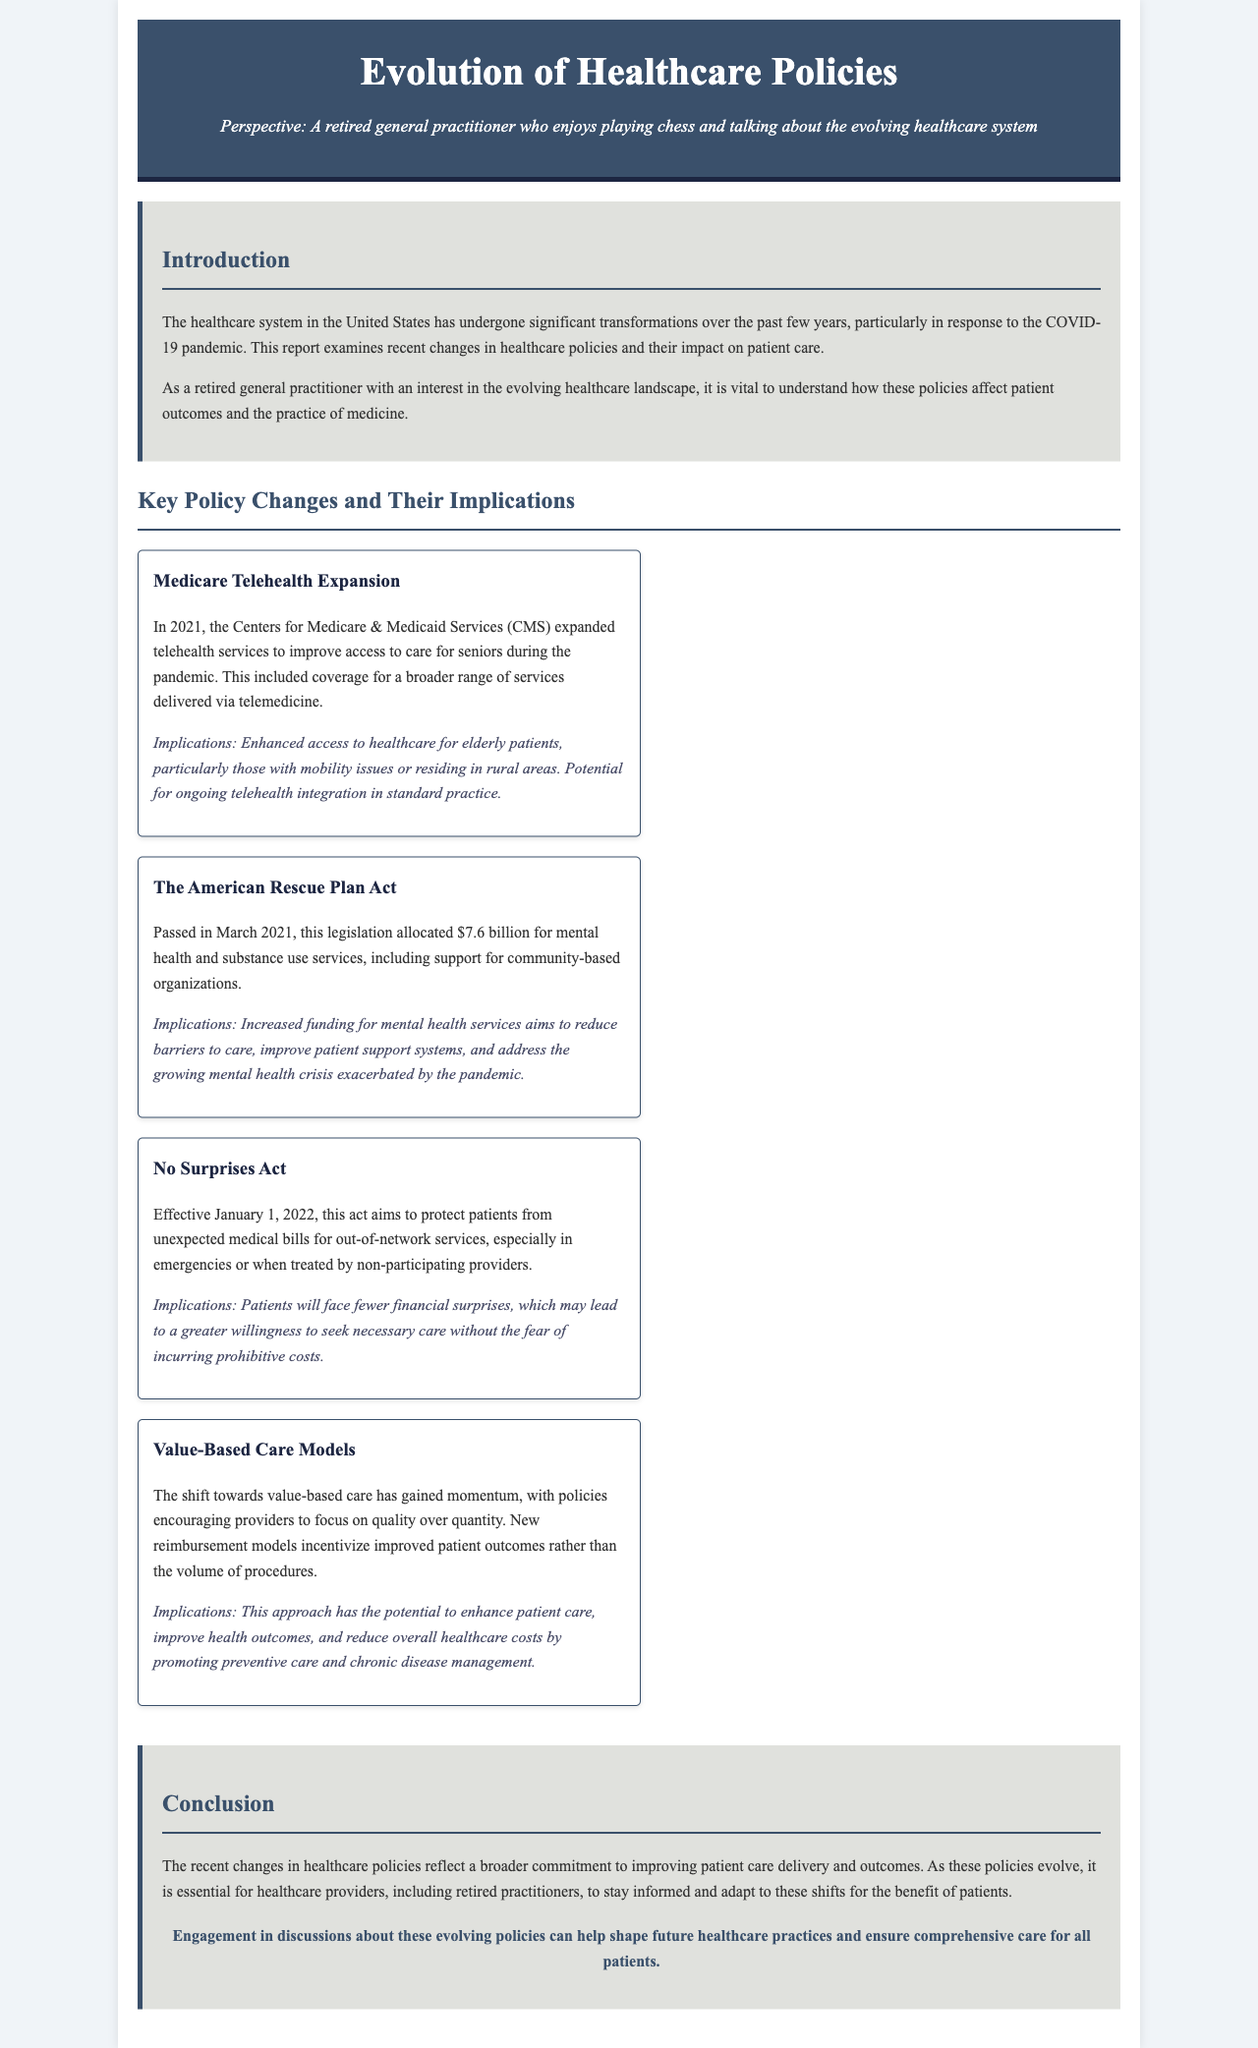What is the title of the report? The title of the report is specified in the heading of the document.
Answer: Evolution of Healthcare Policies Who expanded telehealth services in 2021? The entity responsible for the telehealth expansion is mentioned in the document.
Answer: Centers for Medicare & Medicaid Services What amount was allocated for mental health services under The American Rescue Plan Act? The document states the specific amount allocated for mental health services.
Answer: $7.6 billion When did the No Surprises Act take effect? The effective date of the No Surprises Act is highlighted in the report.
Answer: January 1, 2022 What is the main focus of value-based care models? The document discusses the emphasis of value-based care models.
Answer: Quality over quantity What is one implication of the Medicare Telehealth Expansion? An implication of the telehealth expansion is detailed in the report.
Answer: Enhanced access to healthcare How does the No Surprises Act affect patient care? The document describes how this act impacts patients in terms of costs.
Answer: Fewer financial surprises What major health crisis has been addressed by The American Rescue Plan Act? The document indicates the crisis that prompted the Act's focus on mental health services.
Answer: Growing mental health crisis 